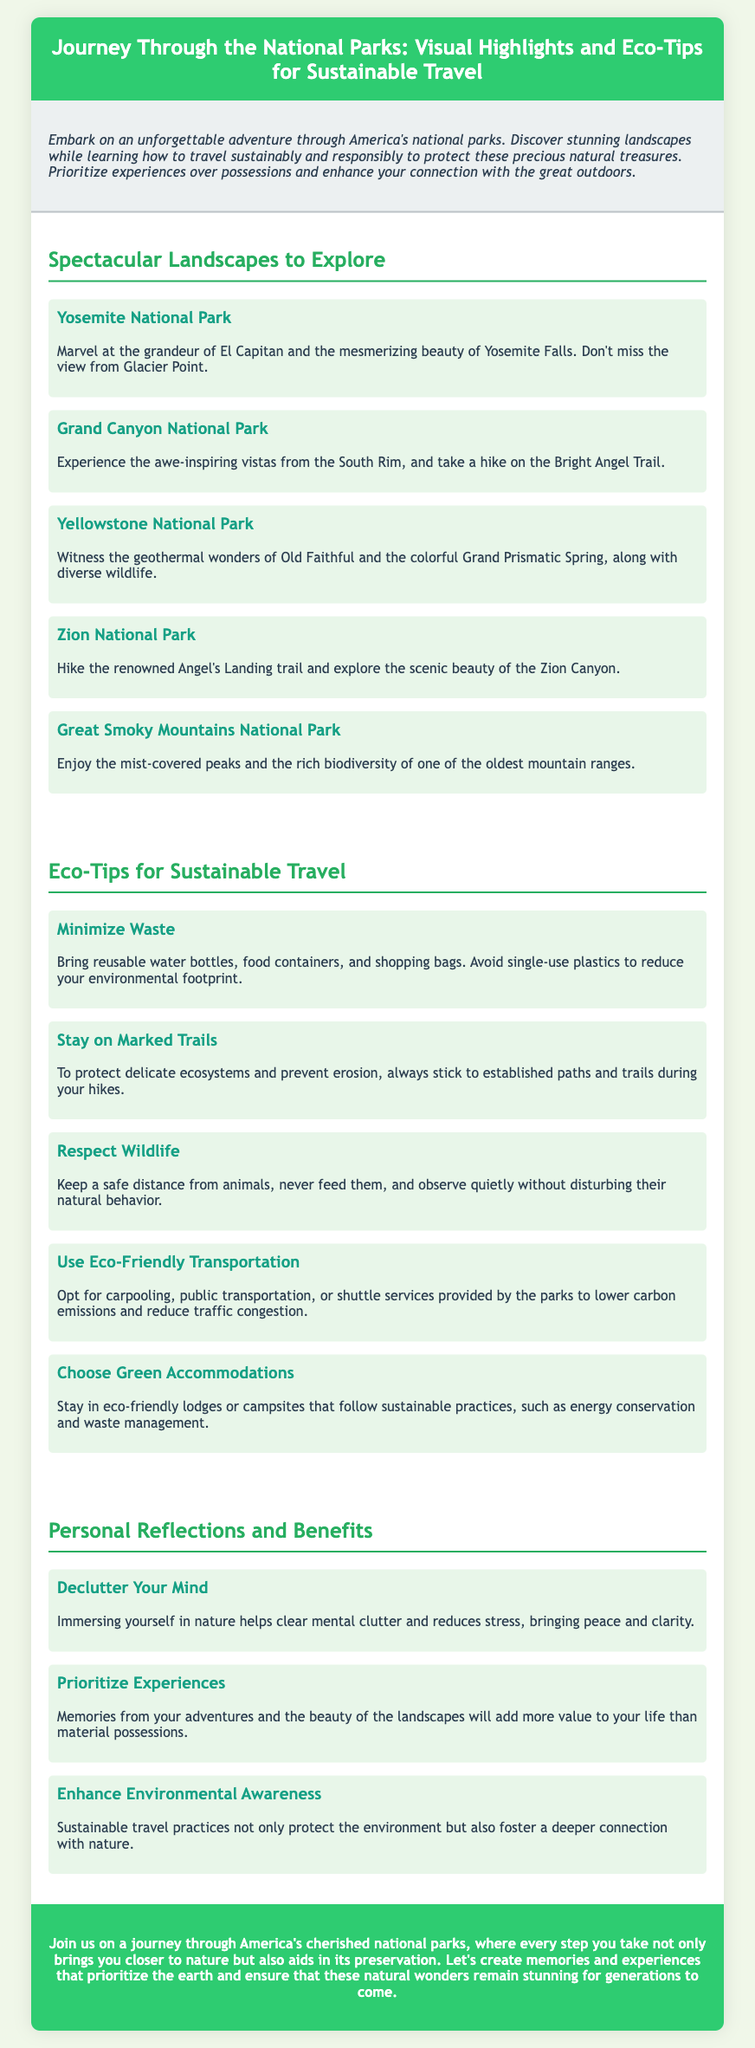what is the title of the document? The title of the document is prominently featured in the header section as the main title.
Answer: Journey Through the National Parks: Visual Highlights and Eco-Tips for Sustainable Travel how many national parks are highlighted? The number of national parks can be found by counting the specific parks listed in the section about landscapes.
Answer: five which national park features El Capitan? This specific information can be found in the description of the park that mentions El Capitan.
Answer: Yosemite National Park what is one way to minimize waste while traveling? The eco-tip section provides specific strategies for sustainable travel, including one about reducing waste.
Answer: Bring reusable water bottles what should travelers do to respect wildlife? The eco-tips include guidelines on how to interact with wildlife in a way that is not harmful.
Answer: Keep a safe distance how does immersing yourself in nature benefit your mind? The reflection section discusses benefits related to mental health from spending time in nature.
Answer: Clears mental clutter what color is used for the section headings in the document? This detail can be found by observing the style choices made for the headings throughout the document.
Answer: Green what type of accommodations should travelers look for? The eco-tips section specifies particular types of places to stay that support sustainable practices.
Answer: Eco-friendly lodges 